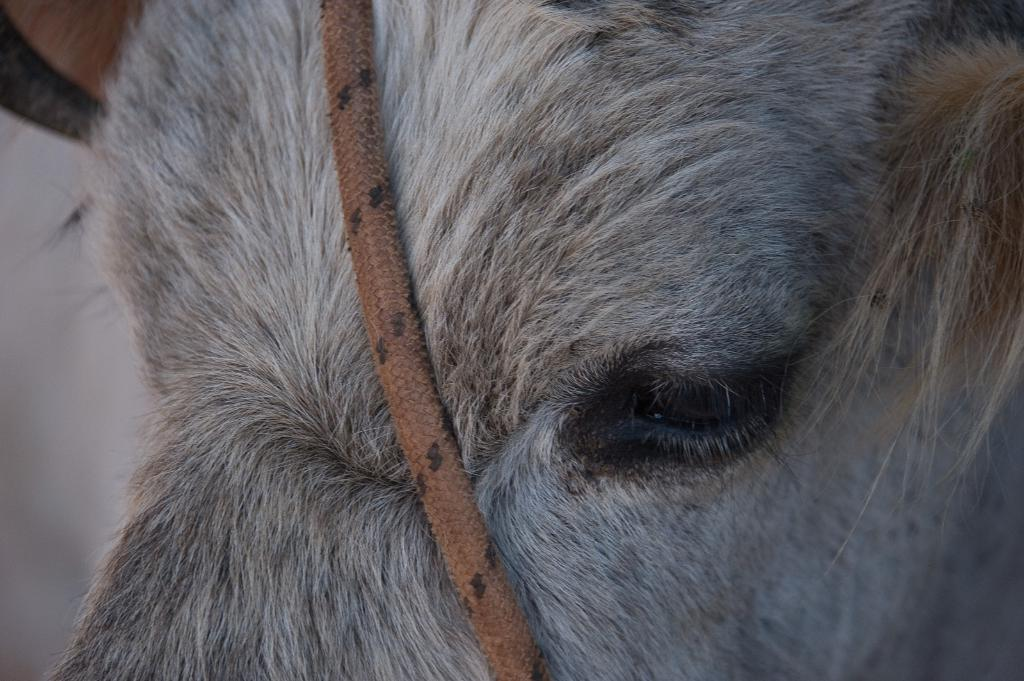What type of animal face can be seen in the image? There is a face of an animal in the image, but the specific animal cannot be determined from the facts provided. What object is located in the middle of the image? There is a rope in the middle of the image. What is the color of the rope? The rope is brown in color. Can you hear the sound of thunder in the image? There is no mention of thunder or any sound in the image, so it cannot be heard. How many trucks are visible in the image? There is no mention of trucks in the image, so the number cannot be determined. 